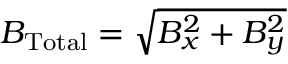<formula> <loc_0><loc_0><loc_500><loc_500>B _ { T o t a l } = \sqrt { B _ { x } ^ { 2 } + B _ { y } ^ { 2 } }</formula> 